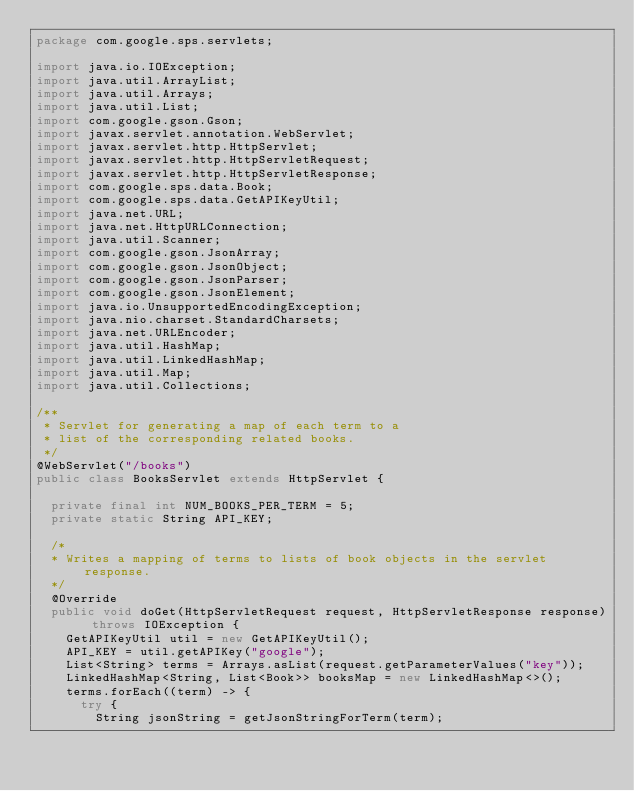<code> <loc_0><loc_0><loc_500><loc_500><_Java_>package com.google.sps.servlets;

import java.io.IOException;
import java.util.ArrayList;
import java.util.Arrays;
import java.util.List;
import com.google.gson.Gson;
import javax.servlet.annotation.WebServlet;
import javax.servlet.http.HttpServlet;
import javax.servlet.http.HttpServletRequest;
import javax.servlet.http.HttpServletResponse;
import com.google.sps.data.Book;
import com.google.sps.data.GetAPIKeyUtil;
import java.net.URL;
import java.net.HttpURLConnection;
import java.util.Scanner;
import com.google.gson.JsonArray;
import com.google.gson.JsonObject;
import com.google.gson.JsonParser;
import com.google.gson.JsonElement;
import java.io.UnsupportedEncodingException;
import java.nio.charset.StandardCharsets;
import java.net.URLEncoder;
import java.util.HashMap;
import java.util.LinkedHashMap;
import java.util.Map;
import java.util.Collections;

/**
 * Servlet for generating a map of each term to a 
 * list of the corresponding related books.
 */
@WebServlet("/books")
public class BooksServlet extends HttpServlet {

  private final int NUM_BOOKS_PER_TERM = 5;
  private static String API_KEY;

  /*
  * Writes a mapping of terms to lists of book objects in the servlet response.
  */
  @Override
  public void doGet(HttpServletRequest request, HttpServletResponse response) throws IOException {
    GetAPIKeyUtil util = new GetAPIKeyUtil();
    API_KEY = util.getAPIKey("google");
    List<String> terms = Arrays.asList(request.getParameterValues("key"));
    LinkedHashMap<String, List<Book>> booksMap = new LinkedHashMap<>();
    terms.forEach((term) -> {
      try {
        String jsonString = getJsonStringForTerm(term);</code> 